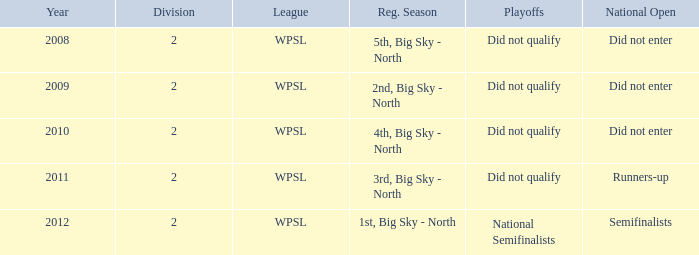What is the maximum number of divisions referred to? 2.0. 